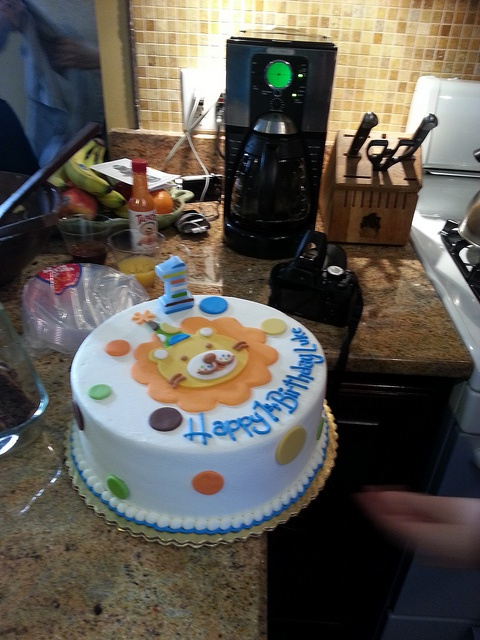Describe the objects in this image and their specific colors. I can see cake in black, gray, darkgray, lightblue, and lightgray tones, oven in black, darkgray, lightgray, and gray tones, people in black, maroon, and gray tones, banana in black, darkgreen, olive, and gray tones, and bottle in black, gray, maroon, and brown tones in this image. 